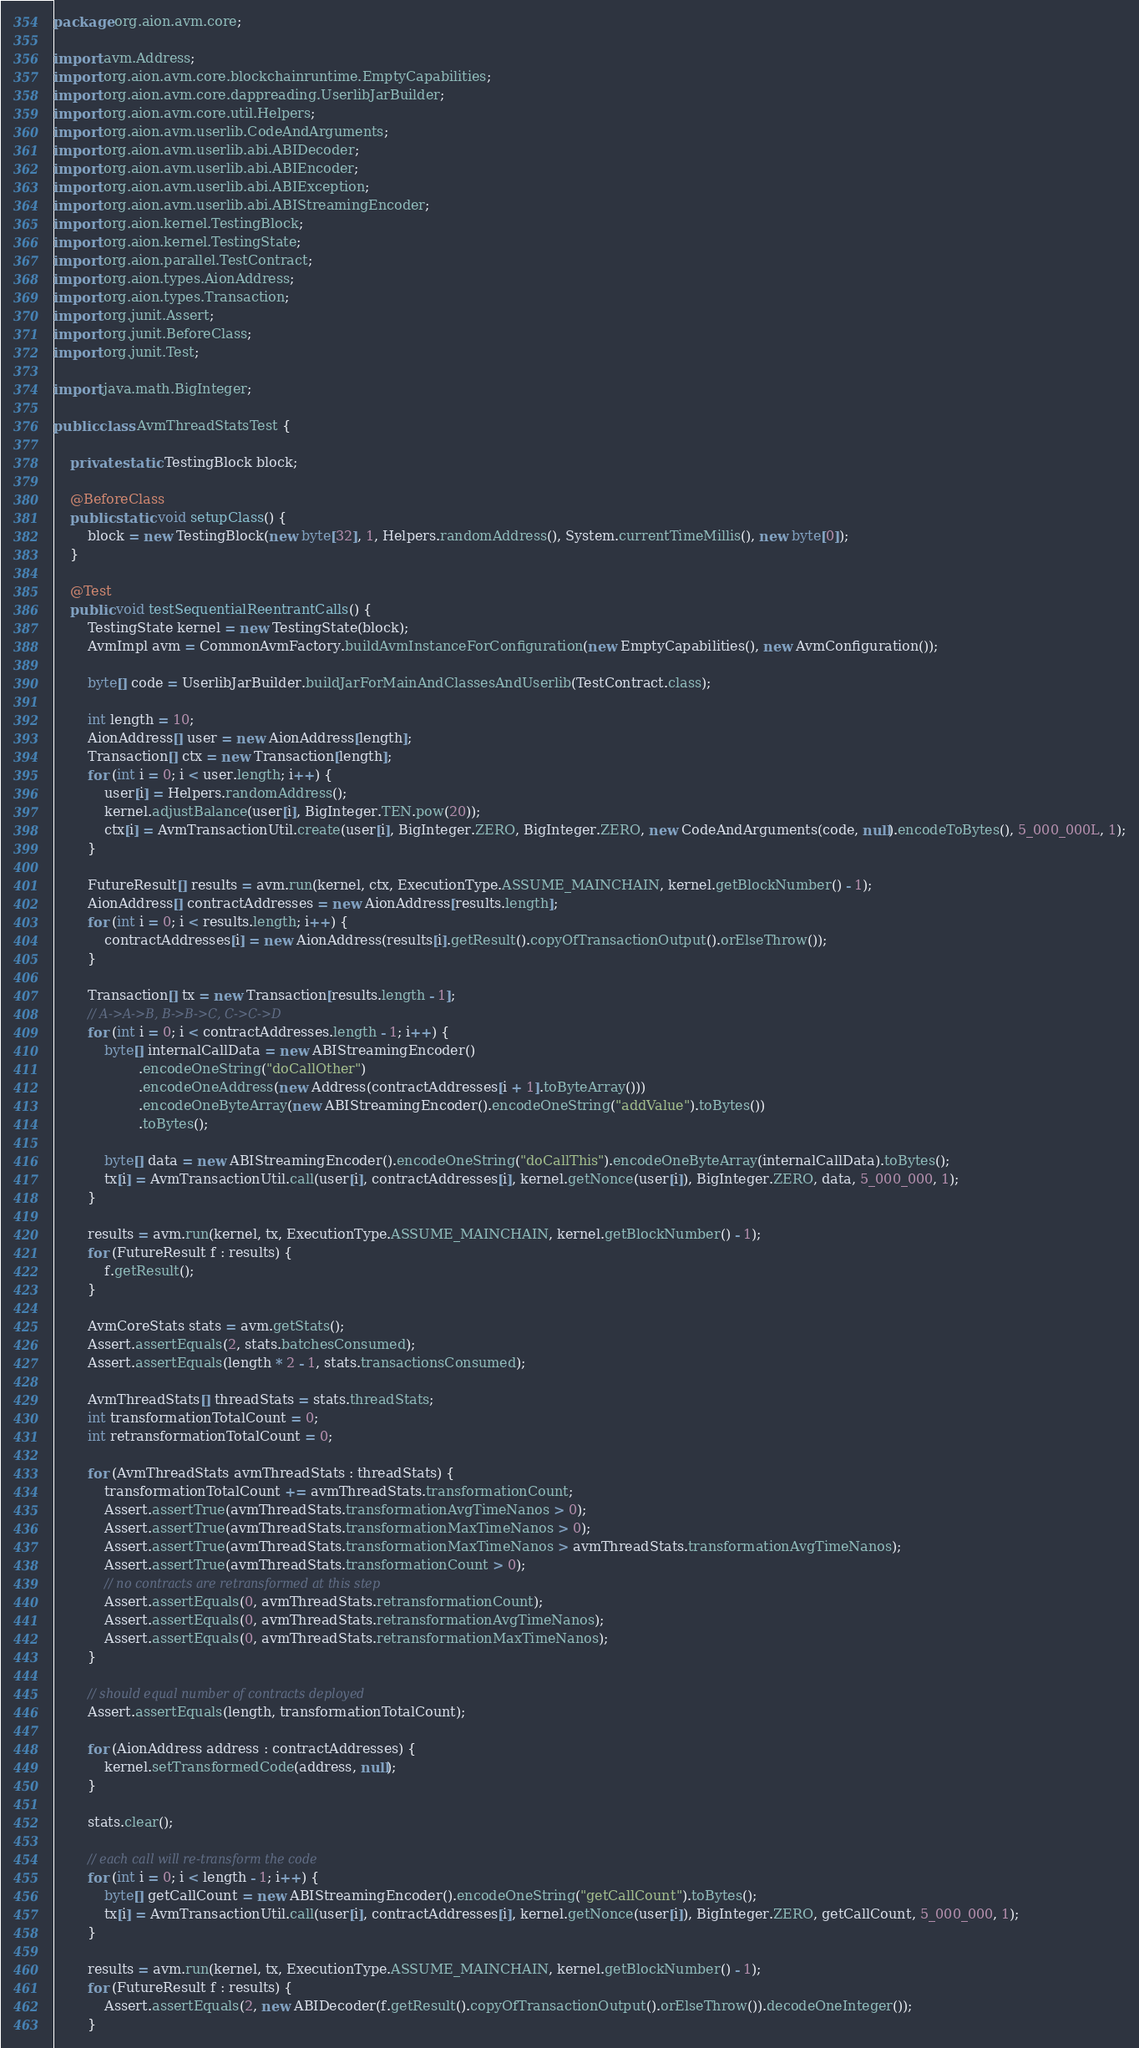Convert code to text. <code><loc_0><loc_0><loc_500><loc_500><_Java_>package org.aion.avm.core;

import avm.Address;
import org.aion.avm.core.blockchainruntime.EmptyCapabilities;
import org.aion.avm.core.dappreading.UserlibJarBuilder;
import org.aion.avm.core.util.Helpers;
import org.aion.avm.userlib.CodeAndArguments;
import org.aion.avm.userlib.abi.ABIDecoder;
import org.aion.avm.userlib.abi.ABIEncoder;
import org.aion.avm.userlib.abi.ABIException;
import org.aion.avm.userlib.abi.ABIStreamingEncoder;
import org.aion.kernel.TestingBlock;
import org.aion.kernel.TestingState;
import org.aion.parallel.TestContract;
import org.aion.types.AionAddress;
import org.aion.types.Transaction;
import org.junit.Assert;
import org.junit.BeforeClass;
import org.junit.Test;

import java.math.BigInteger;

public class AvmThreadStatsTest {

    private static TestingBlock block;

    @BeforeClass
    public static void setupClass() {
        block = new TestingBlock(new byte[32], 1, Helpers.randomAddress(), System.currentTimeMillis(), new byte[0]);
    }

    @Test
    public void testSequentialReentrantCalls() {
        TestingState kernel = new TestingState(block);
        AvmImpl avm = CommonAvmFactory.buildAvmInstanceForConfiguration(new EmptyCapabilities(), new AvmConfiguration());

        byte[] code = UserlibJarBuilder.buildJarForMainAndClassesAndUserlib(TestContract.class);

        int length = 10;
        AionAddress[] user = new AionAddress[length];
        Transaction[] ctx = new Transaction[length];
        for (int i = 0; i < user.length; i++) {
            user[i] = Helpers.randomAddress();
            kernel.adjustBalance(user[i], BigInteger.TEN.pow(20));
            ctx[i] = AvmTransactionUtil.create(user[i], BigInteger.ZERO, BigInteger.ZERO, new CodeAndArguments(code, null).encodeToBytes(), 5_000_000L, 1);
        }

        FutureResult[] results = avm.run(kernel, ctx, ExecutionType.ASSUME_MAINCHAIN, kernel.getBlockNumber() - 1);
        AionAddress[] contractAddresses = new AionAddress[results.length];
        for (int i = 0; i < results.length; i++) {
            contractAddresses[i] = new AionAddress(results[i].getResult().copyOfTransactionOutput().orElseThrow());
        }

        Transaction[] tx = new Transaction[results.length - 1];
        // A->A->B, B->B->C, C->C->D
        for (int i = 0; i < contractAddresses.length - 1; i++) {
            byte[] internalCallData = new ABIStreamingEncoder()
                    .encodeOneString("doCallOther")
                    .encodeOneAddress(new Address(contractAddresses[i + 1].toByteArray()))
                    .encodeOneByteArray(new ABIStreamingEncoder().encodeOneString("addValue").toBytes())
                    .toBytes();

            byte[] data = new ABIStreamingEncoder().encodeOneString("doCallThis").encodeOneByteArray(internalCallData).toBytes();
            tx[i] = AvmTransactionUtil.call(user[i], contractAddresses[i], kernel.getNonce(user[i]), BigInteger.ZERO, data, 5_000_000, 1);
        }

        results = avm.run(kernel, tx, ExecutionType.ASSUME_MAINCHAIN, kernel.getBlockNumber() - 1);
        for (FutureResult f : results) {
            f.getResult();
        }

        AvmCoreStats stats = avm.getStats();
        Assert.assertEquals(2, stats.batchesConsumed);
        Assert.assertEquals(length * 2 - 1, stats.transactionsConsumed);

        AvmThreadStats[] threadStats = stats.threadStats;
        int transformationTotalCount = 0;
        int retransformationTotalCount = 0;

        for (AvmThreadStats avmThreadStats : threadStats) {
            transformationTotalCount += avmThreadStats.transformationCount;
            Assert.assertTrue(avmThreadStats.transformationAvgTimeNanos > 0);
            Assert.assertTrue(avmThreadStats.transformationMaxTimeNanos > 0);
            Assert.assertTrue(avmThreadStats.transformationMaxTimeNanos > avmThreadStats.transformationAvgTimeNanos);
            Assert.assertTrue(avmThreadStats.transformationCount > 0);
            // no contracts are retransformed at this step
            Assert.assertEquals(0, avmThreadStats.retransformationCount);
            Assert.assertEquals(0, avmThreadStats.retransformationAvgTimeNanos);
            Assert.assertEquals(0, avmThreadStats.retransformationMaxTimeNanos);
        }

        // should equal number of contracts deployed
        Assert.assertEquals(length, transformationTotalCount);

        for (AionAddress address : contractAddresses) {
            kernel.setTransformedCode(address, null);
        }

        stats.clear();

        // each call will re-transform the code
        for (int i = 0; i < length - 1; i++) {
            byte[] getCallCount = new ABIStreamingEncoder().encodeOneString("getCallCount").toBytes();
            tx[i] = AvmTransactionUtil.call(user[i], contractAddresses[i], kernel.getNonce(user[i]), BigInteger.ZERO, getCallCount, 5_000_000, 1);
        }

        results = avm.run(kernel, tx, ExecutionType.ASSUME_MAINCHAIN, kernel.getBlockNumber() - 1);
        for (FutureResult f : results) {
            Assert.assertEquals(2, new ABIDecoder(f.getResult().copyOfTransactionOutput().orElseThrow()).decodeOneInteger());
        }
</code> 